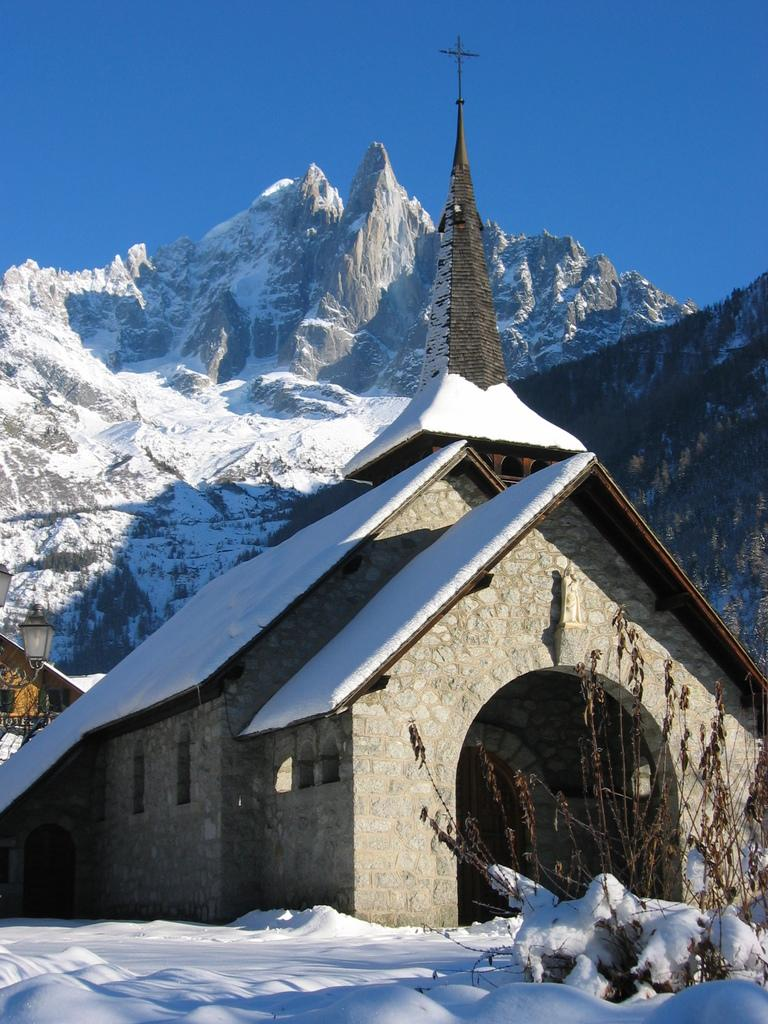What type of plant is visible in the image? There is a plant in the image. What is the weather like in the image? There is snow in the image, indicating a cold or wintery environment. What type of structures can be seen in the image? There are houses in the image. What religious symbol is present in the image? There is a cross symbol in the image. What type of lighting is visible in the image? There are lights in the image. What type of natural vegetation is present in the image? There are trees in the image. What type of geographical feature is visible in the image? There is a mountain in the image. What color is the sky in the image? The sky is blue in the image. Where are the tomatoes being stored in the image? There are no tomatoes present in the image. What type of desk is visible in the image? There is no desk present in the image. 